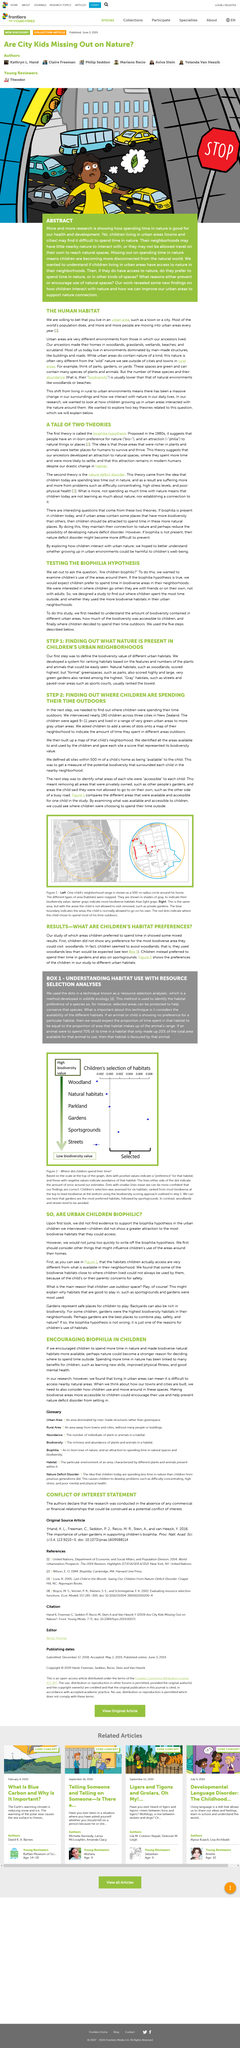Outline some significant characteristics in this image. The Biophilia Hypothesis study was designed to investigate where children spend the most time outside in their urban neighborhoods and whether they utilize the more biodiverse habitats in their surroundings. The study aimed to promote a love for nature in children by encouraging biophilia. Good mental health is not the only benefit of spending more time in nature. In this study, it was observed that children tended to avoid the most biodiverse area they could visit, which was the woodlands. In order to prevent the onset of nature deficit disorder in children, it is imperative to make biodiverse areas more accessible to them. 